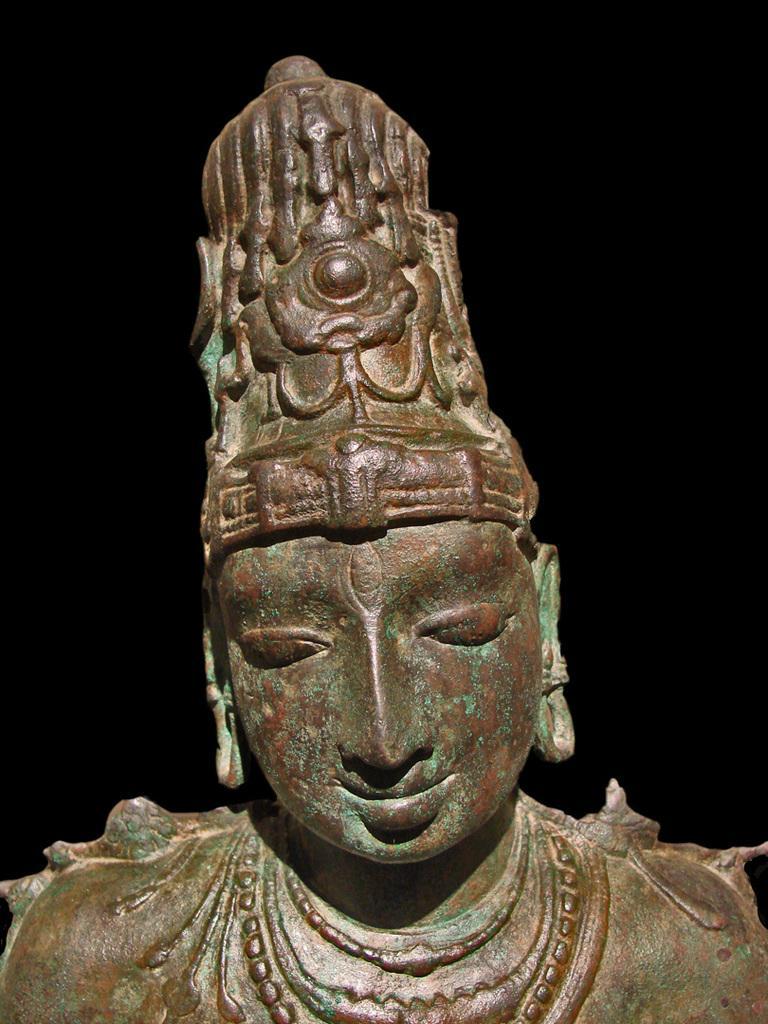Please provide a concise description of this image. In the image in the center we can see one sculpture,which is in brown color. 